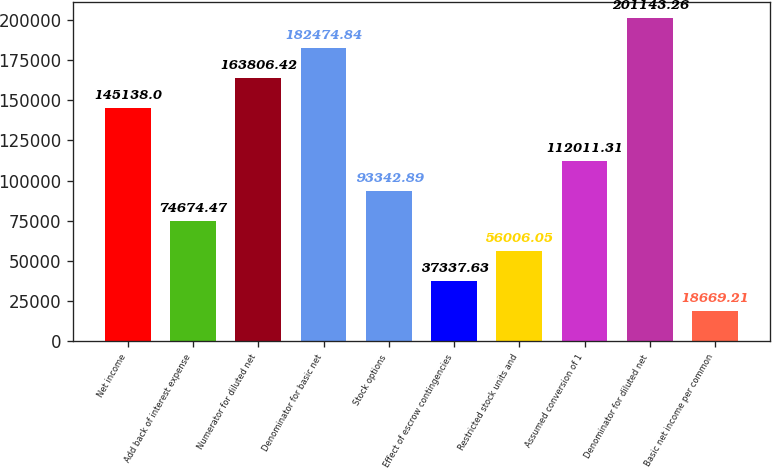<chart> <loc_0><loc_0><loc_500><loc_500><bar_chart><fcel>Net income<fcel>Add back of interest expense<fcel>Numerator for diluted net<fcel>Denominator for basic net<fcel>Stock options<fcel>Effect of escrow contingencies<fcel>Restricted stock units and<fcel>Assumed conversion of 1<fcel>Denominator for diluted net<fcel>Basic net income per common<nl><fcel>145138<fcel>74674.5<fcel>163806<fcel>182475<fcel>93342.9<fcel>37337.6<fcel>56006.1<fcel>112011<fcel>201143<fcel>18669.2<nl></chart> 